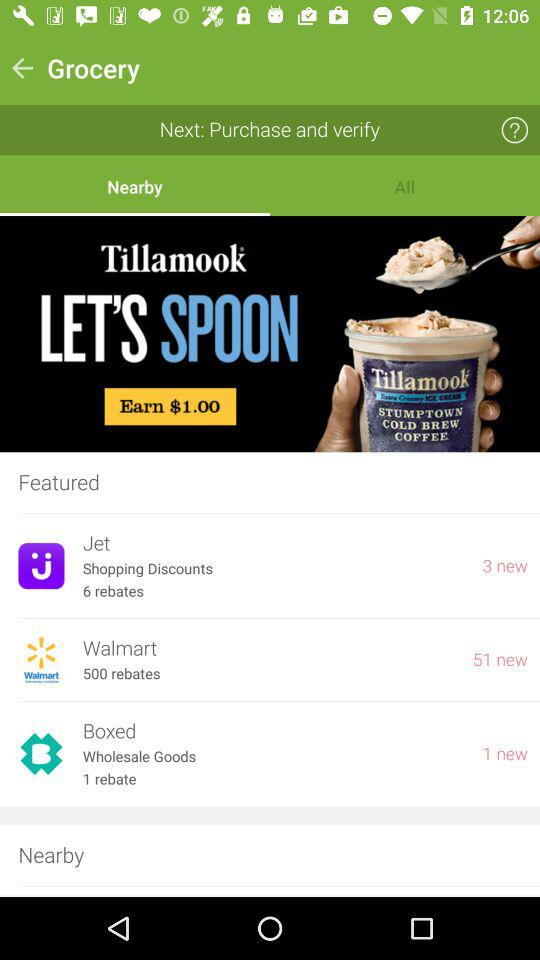How much can we earn on "Tillamook" cold coffee? You can earn $1.00. 